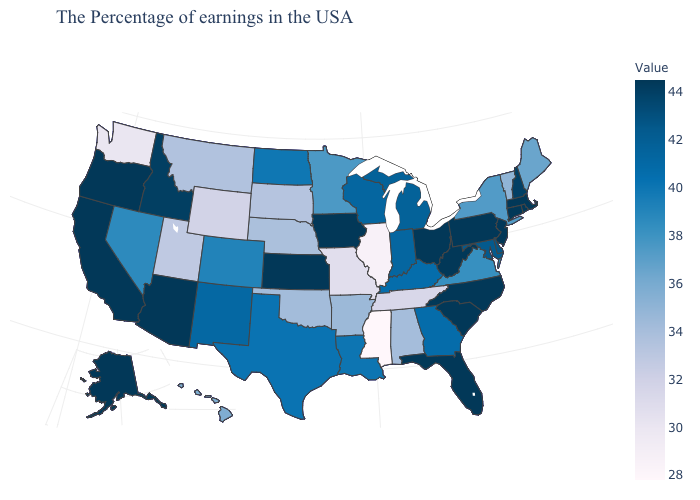Which states hav the highest value in the South?
Quick response, please. North Carolina, South Carolina, West Virginia, Florida. Among the states that border Utah , does Arizona have the highest value?
Answer briefly. Yes. Does North Dakota have the highest value in the MidWest?
Be succinct. No. Does New Mexico have the highest value in the West?
Give a very brief answer. No. 